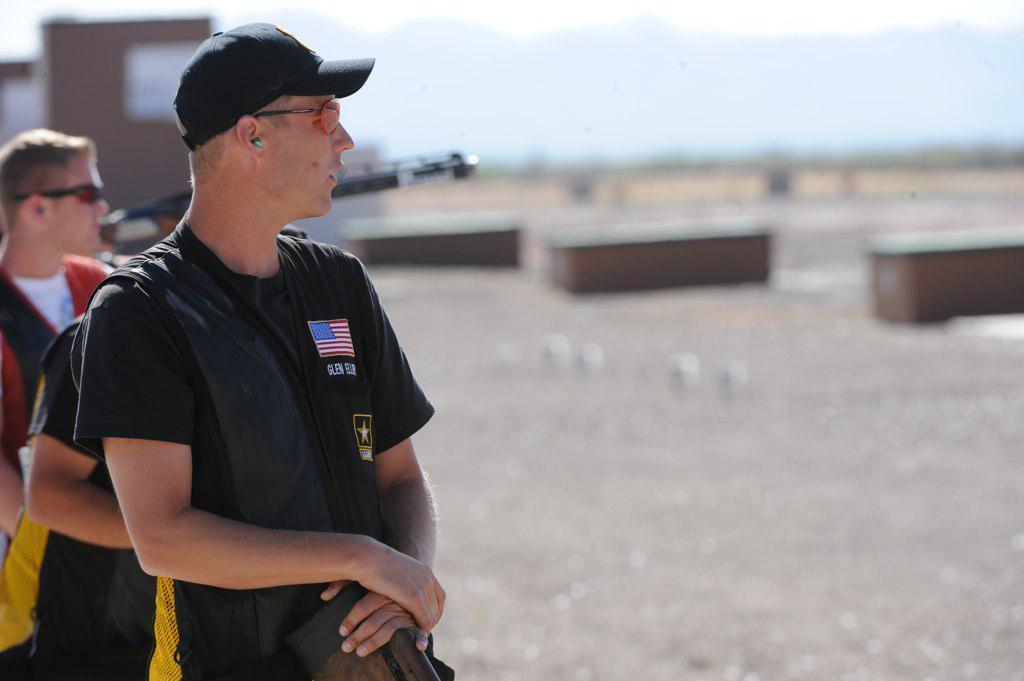In one or two sentences, can you explain what this image depicts? In this image on the left side there are persons standing and in the center there is a house and the background is blurry. 